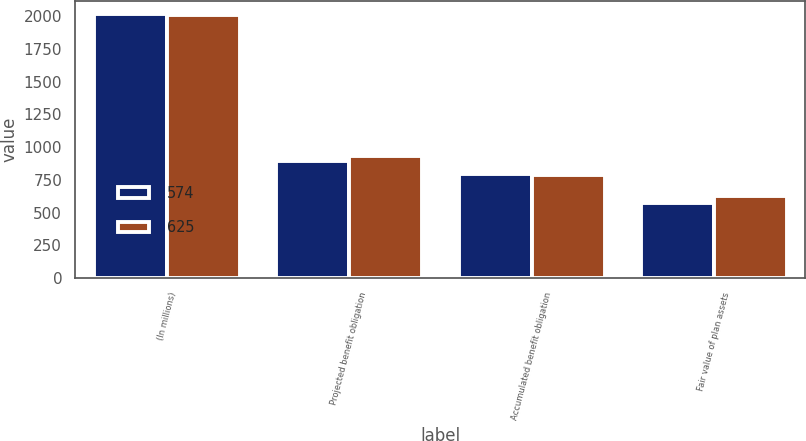Convert chart to OTSL. <chart><loc_0><loc_0><loc_500><loc_500><stacked_bar_chart><ecel><fcel>(In millions)<fcel>Projected benefit obligation<fcel>Accumulated benefit obligation<fcel>Fair value of plan assets<nl><fcel>574<fcel>2014<fcel>894<fcel>793<fcel>574<nl><fcel>625<fcel>2013<fcel>933<fcel>791<fcel>625<nl></chart> 